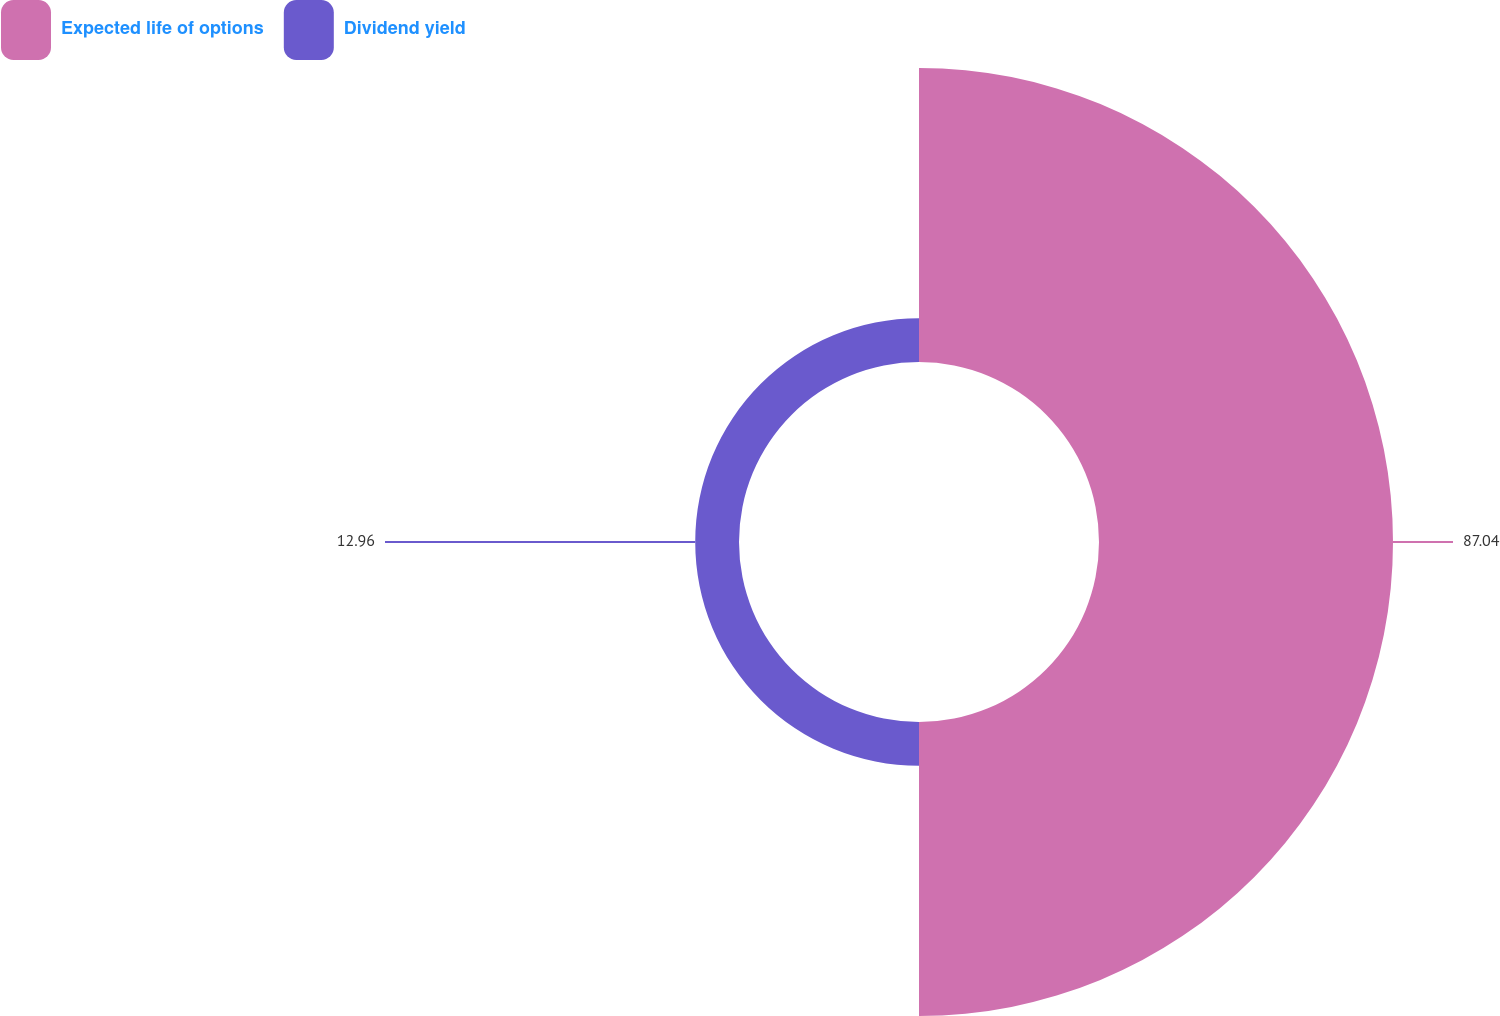Convert chart. <chart><loc_0><loc_0><loc_500><loc_500><pie_chart><fcel>Expected life of options<fcel>Dividend yield<nl><fcel>87.04%<fcel>12.96%<nl></chart> 